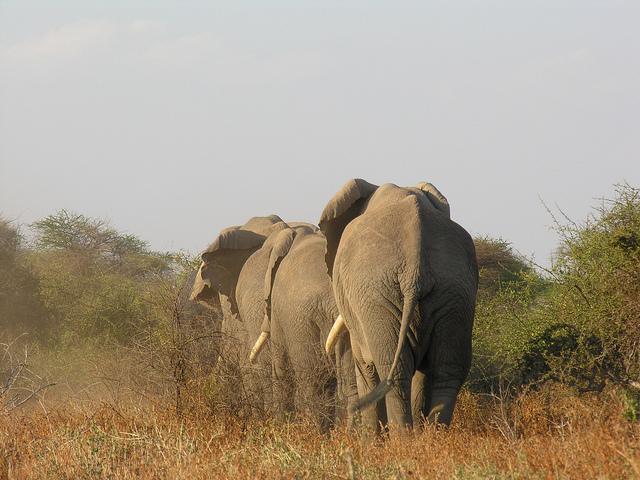How many elephants are in the photo?
Give a very brief answer. 3. How many elephants are there?
Give a very brief answer. 3. 